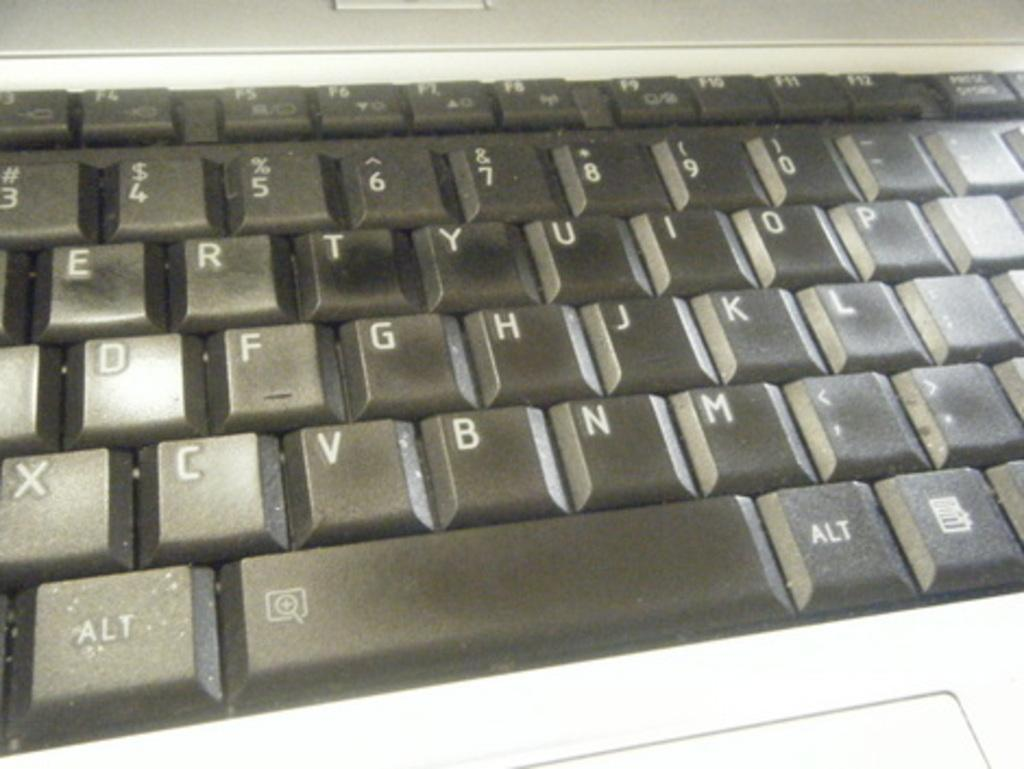Provide a one-sentence caption for the provided image. A black keyboard that shows some buttons like the alt key. 